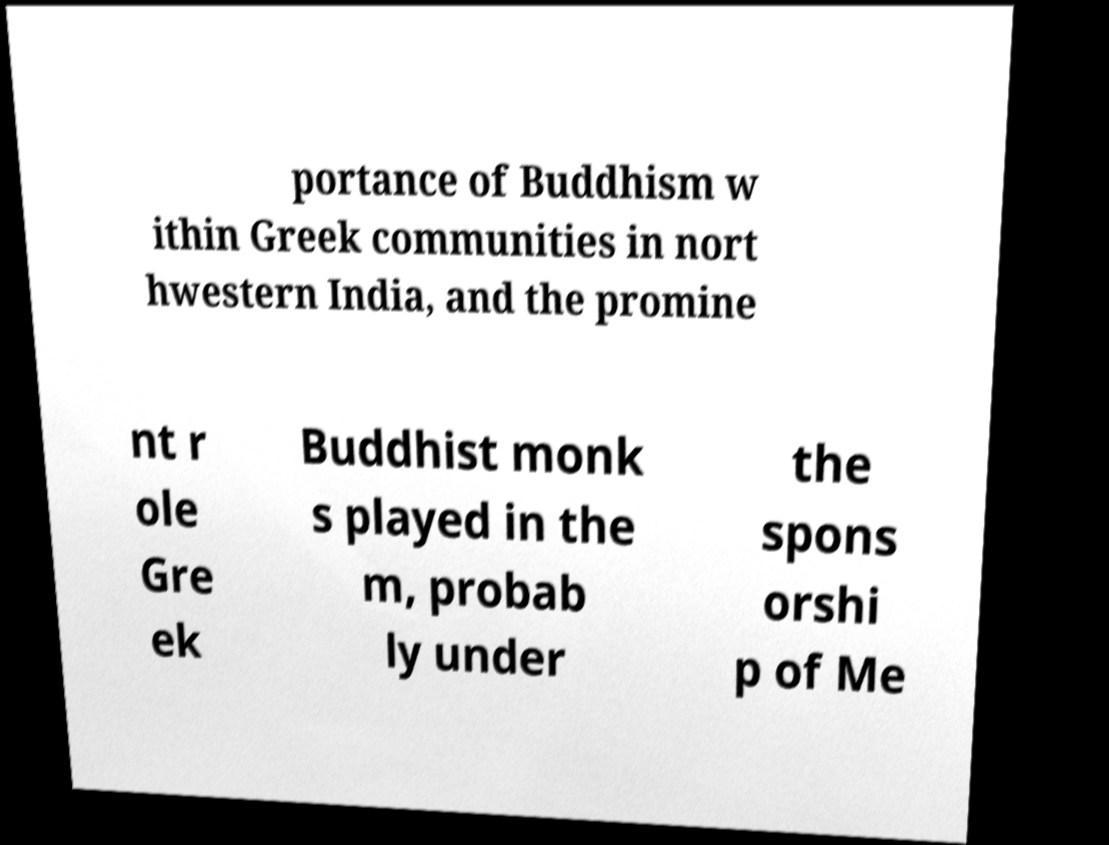Can you accurately transcribe the text from the provided image for me? portance of Buddhism w ithin Greek communities in nort hwestern India, and the promine nt r ole Gre ek Buddhist monk s played in the m, probab ly under the spons orshi p of Me 